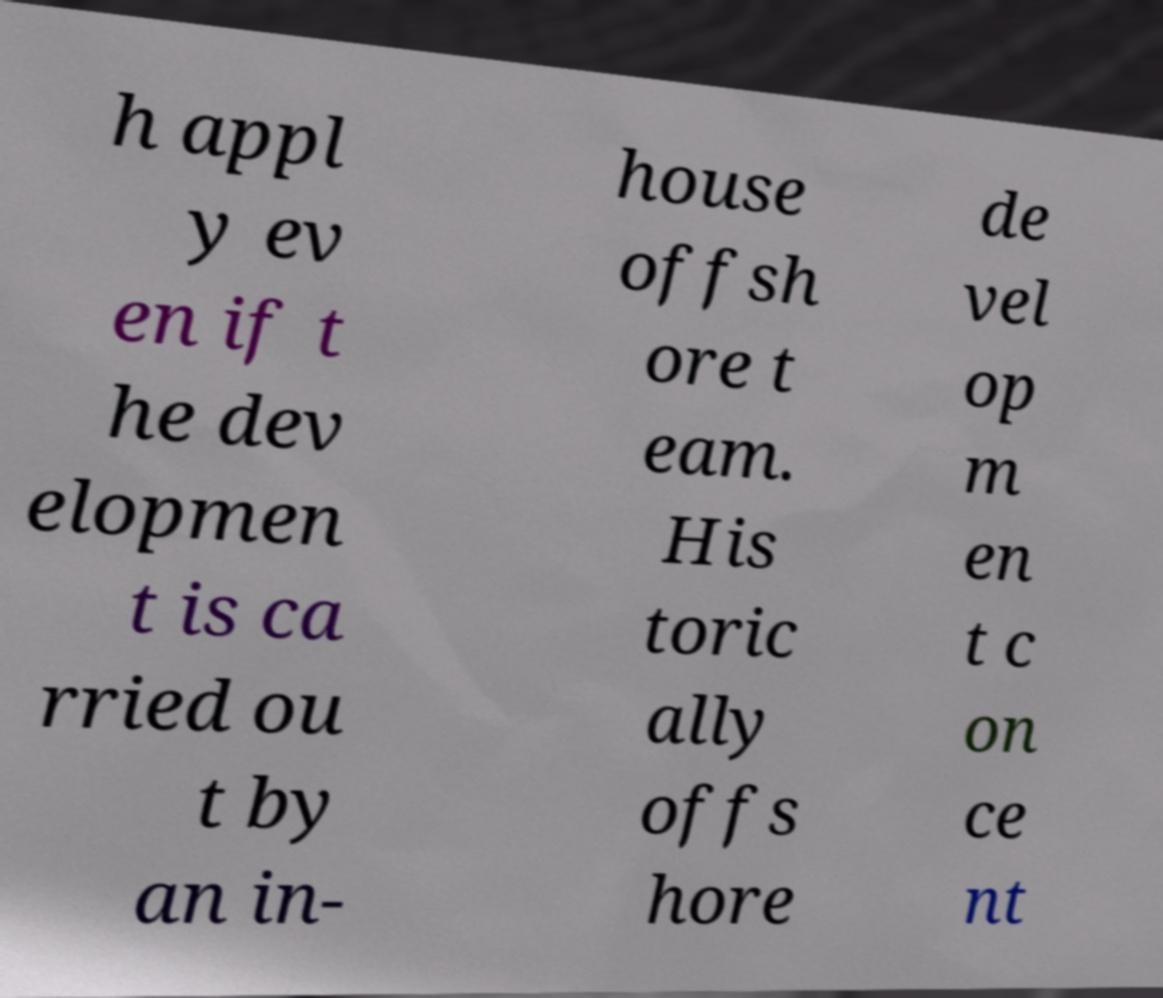Can you accurately transcribe the text from the provided image for me? h appl y ev en if t he dev elopmen t is ca rried ou t by an in- house offsh ore t eam. His toric ally offs hore de vel op m en t c on ce nt 